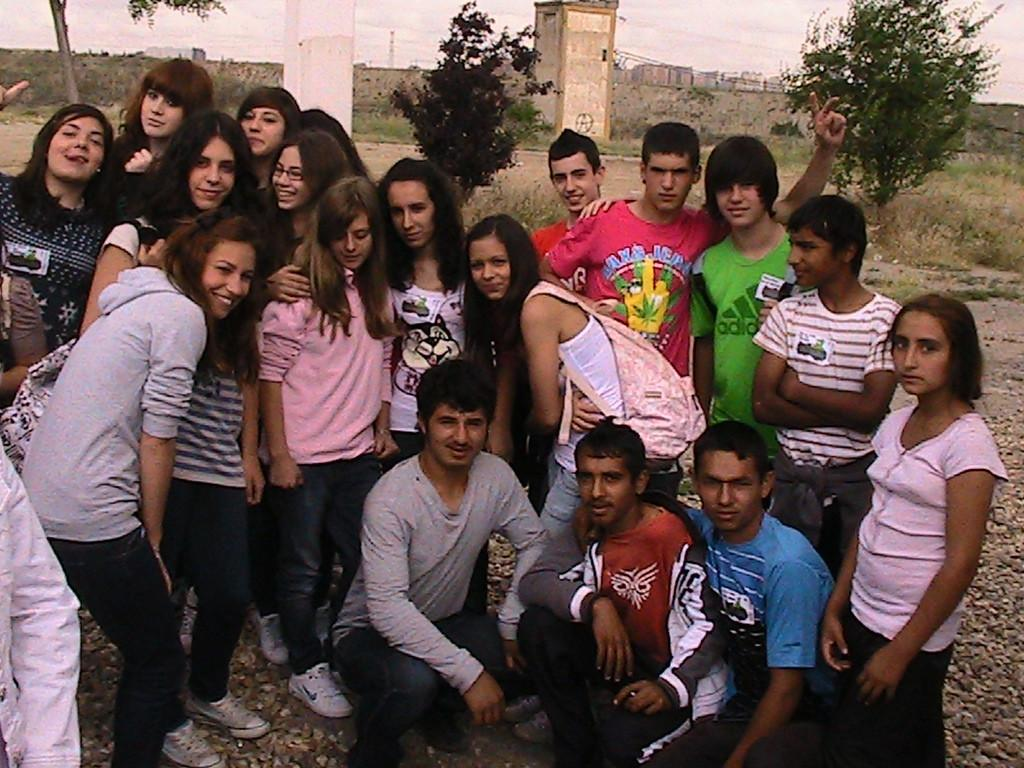Who or what can be seen in the image? There are people in the image. What is visible in the background of the image? There is a wall, buildings, the sky, and trees in the background of the image. What type of wrench is being used by the people in the image? There is no wrench present in the image; it features people and a background with a wall, buildings, sky, and trees. 